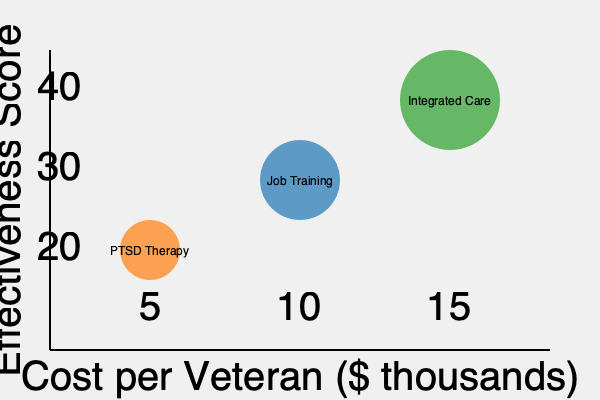Based on the bubble chart depicting various veterans' mental health initiatives, which program offers the best balance of cost-effectiveness and overall impact, considering both the effectiveness score and the number of veterans served (represented by bubble size)? To determine the best balance of cost-effectiveness and overall impact, we need to consider three factors for each program:

1. Cost per veteran (x-axis)
2. Effectiveness score (y-axis)
3. Number of veterans served (bubble size)

Let's analyze each program:

1. PTSD Therapy:
   - Cost: ~$5,000 per veteran
   - Effectiveness score: ~20
   - Relatively small number of veterans served

2. Job Training:
   - Cost: ~$10,000 per veteran
   - Effectiveness score: ~30
   - Moderate number of veterans served

3. Integrated Care:
   - Cost: ~$15,000 per veteran
   - Effectiveness score: ~40
   - Largest number of veterans served

To evaluate cost-effectiveness, we can calculate a simple ratio:

$\text{Cost-effectiveness ratio} = \frac{\text{Effectiveness score}}{\text{Cost per veteran}}$

PTSD Therapy: $\frac{20}{5} = 4$
Job Training: $\frac{30}{10} = 3$
Integrated Care: $\frac{40}{15} \approx 2.67$

While PTSD Therapy has the highest cost-effectiveness ratio, it serves the smallest number of veterans. Job Training offers a good balance between cost-effectiveness and the number of veterans served. Integrated Care, although having the lowest cost-effectiveness ratio, serves the largest number of veterans and has the highest overall effectiveness score.

Considering the government official's budget-conscious perspective and the need for broad impact, the Job Training program offers the best balance of cost-effectiveness and overall impact. It provides a good effectiveness score, serves a moderate number of veterans, and maintains a reasonable cost per veteran.
Answer: Job Training program 